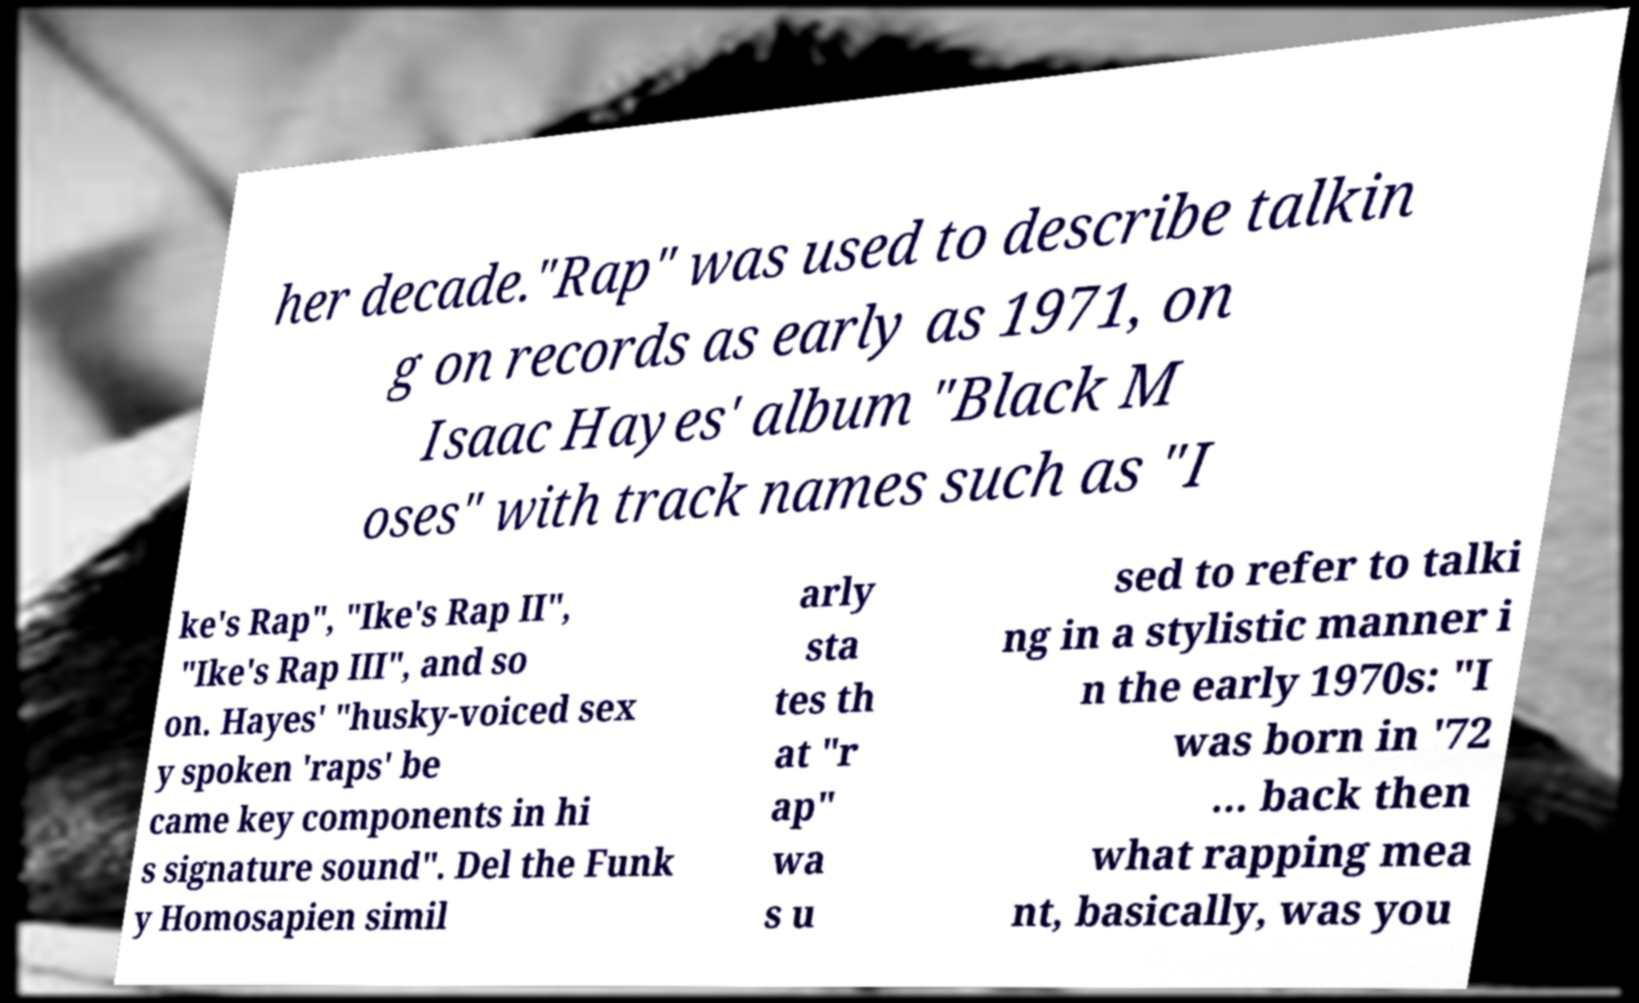Could you assist in decoding the text presented in this image and type it out clearly? her decade."Rap" was used to describe talkin g on records as early as 1971, on Isaac Hayes' album "Black M oses" with track names such as "I ke's Rap", "Ike's Rap II", "Ike's Rap III", and so on. Hayes' "husky-voiced sex y spoken 'raps' be came key components in hi s signature sound". Del the Funk y Homosapien simil arly sta tes th at "r ap" wa s u sed to refer to talki ng in a stylistic manner i n the early 1970s: "I was born in '72 ... back then what rapping mea nt, basically, was you 